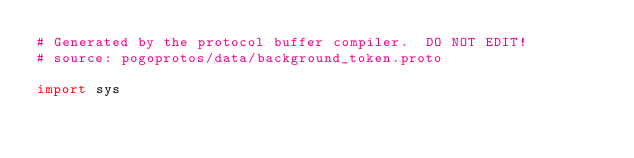<code> <loc_0><loc_0><loc_500><loc_500><_Python_># Generated by the protocol buffer compiler.  DO NOT EDIT!
# source: pogoprotos/data/background_token.proto

import sys</code> 